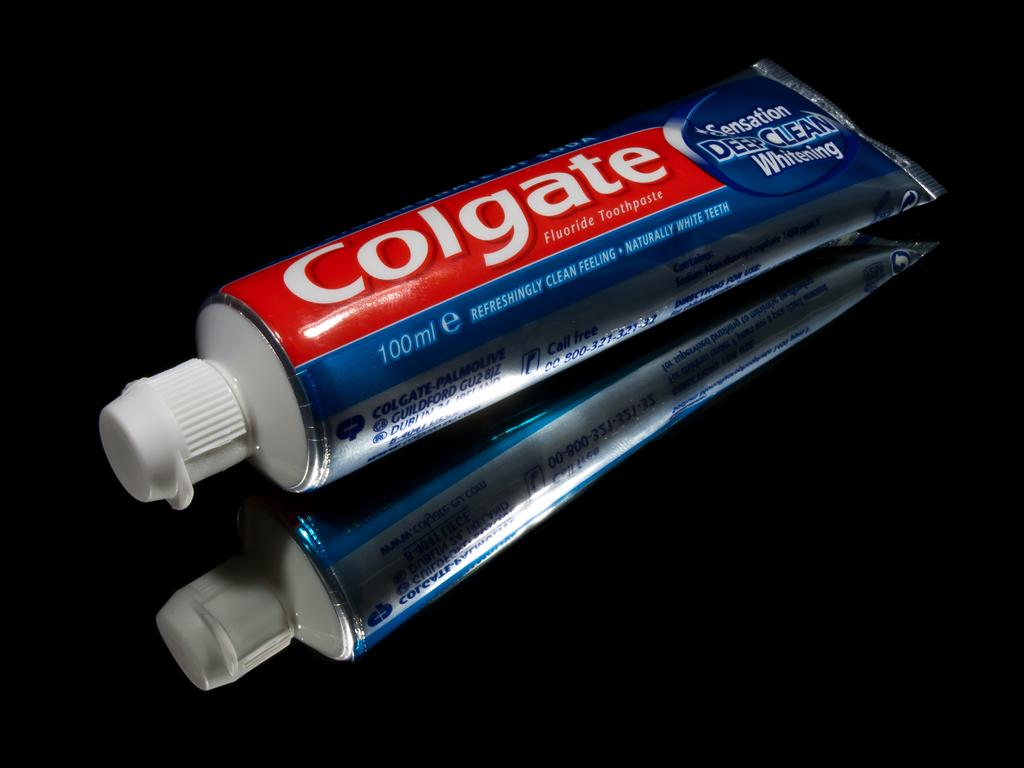<image>
Present a compact description of the photo's key features. tube of colgate sensation deep clean whitening toothpaste on a dark reflective surface 